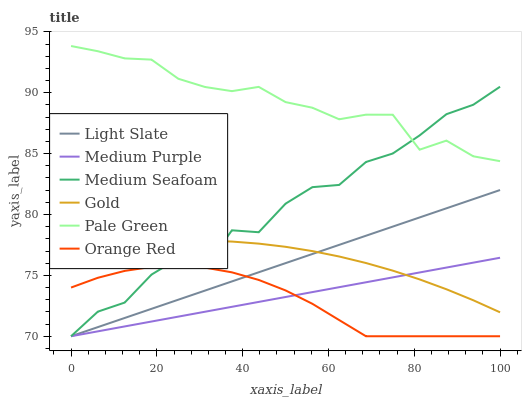Does Orange Red have the minimum area under the curve?
Answer yes or no. Yes. Does Pale Green have the maximum area under the curve?
Answer yes or no. Yes. Does Light Slate have the minimum area under the curve?
Answer yes or no. No. Does Light Slate have the maximum area under the curve?
Answer yes or no. No. Is Light Slate the smoothest?
Answer yes or no. Yes. Is Medium Seafoam the roughest?
Answer yes or no. Yes. Is Orange Red the smoothest?
Answer yes or no. No. Is Orange Red the roughest?
Answer yes or no. No. Does Light Slate have the lowest value?
Answer yes or no. Yes. Does Pale Green have the lowest value?
Answer yes or no. No. Does Pale Green have the highest value?
Answer yes or no. Yes. Does Light Slate have the highest value?
Answer yes or no. No. Is Orange Red less than Pale Green?
Answer yes or no. Yes. Is Pale Green greater than Light Slate?
Answer yes or no. Yes. Does Light Slate intersect Gold?
Answer yes or no. Yes. Is Light Slate less than Gold?
Answer yes or no. No. Is Light Slate greater than Gold?
Answer yes or no. No. Does Orange Red intersect Pale Green?
Answer yes or no. No. 